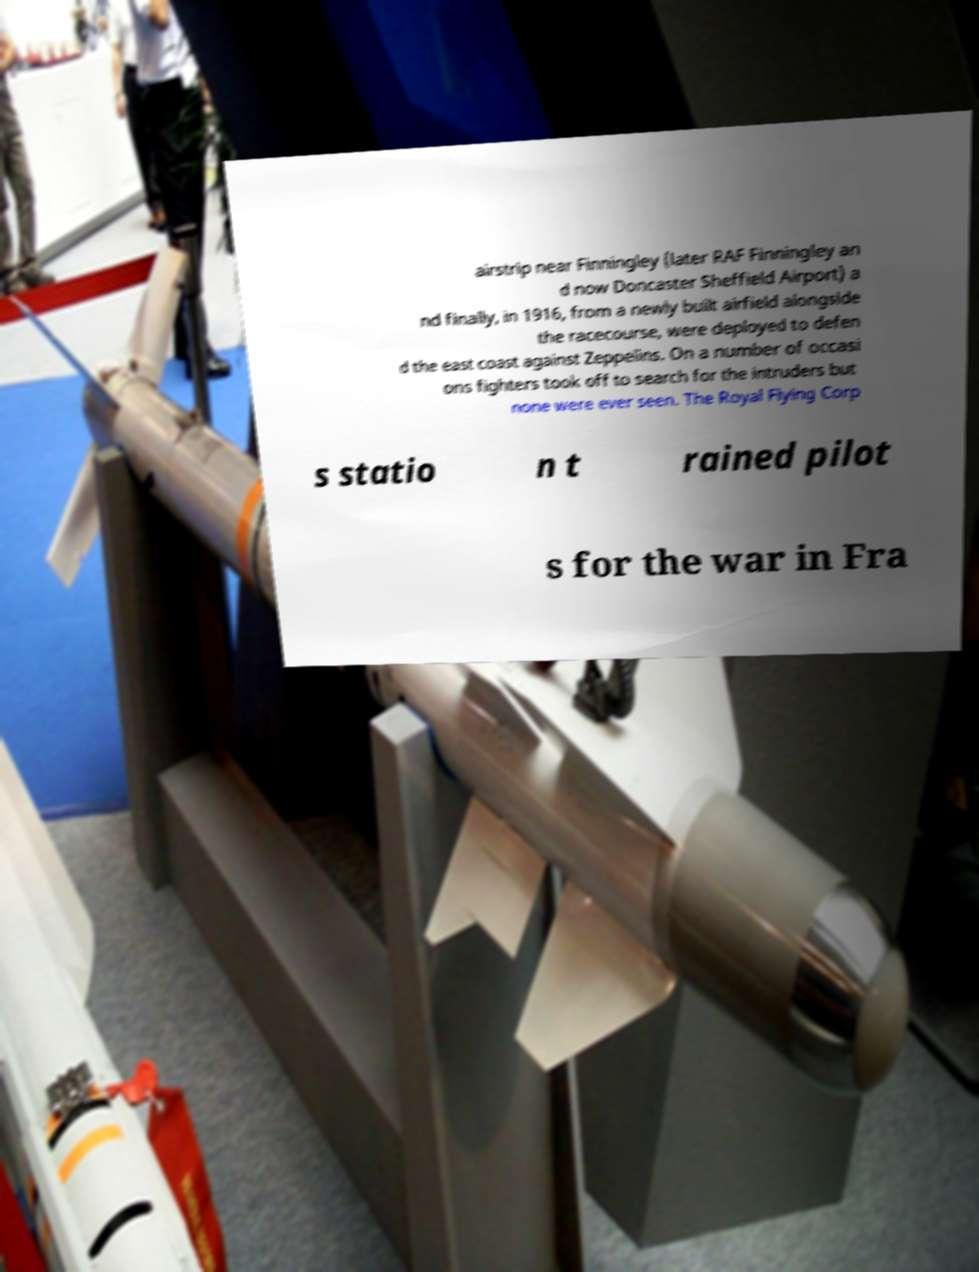Could you extract and type out the text from this image? airstrip near Finningley (later RAF Finningley an d now Doncaster Sheffield Airport) a nd finally, in 1916, from a newly built airfield alongside the racecourse, were deployed to defen d the east coast against Zeppelins. On a number of occasi ons fighters took off to search for the intruders but none were ever seen. The Royal Flying Corp s statio n t rained pilot s for the war in Fra 